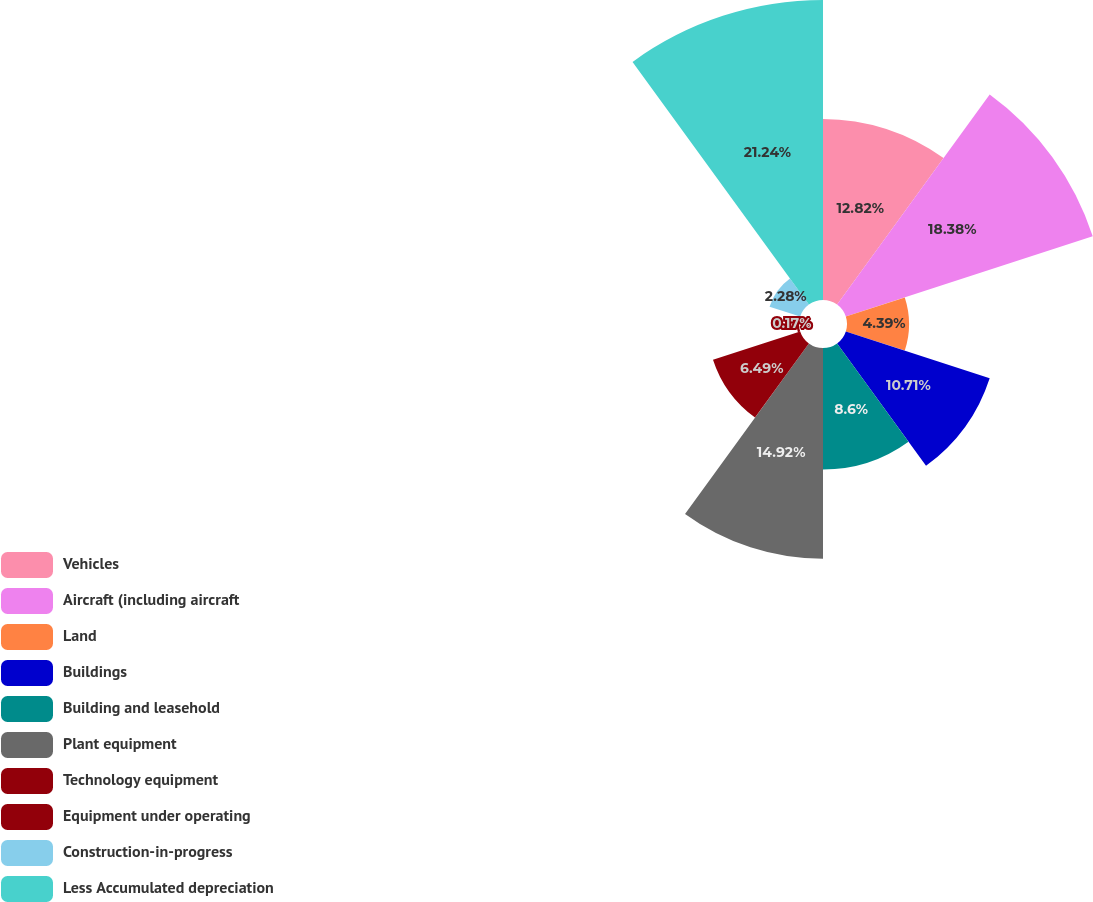Convert chart to OTSL. <chart><loc_0><loc_0><loc_500><loc_500><pie_chart><fcel>Vehicles<fcel>Aircraft (including aircraft<fcel>Land<fcel>Buildings<fcel>Building and leasehold<fcel>Plant equipment<fcel>Technology equipment<fcel>Equipment under operating<fcel>Construction-in-progress<fcel>Less Accumulated depreciation<nl><fcel>12.82%<fcel>18.38%<fcel>4.39%<fcel>10.71%<fcel>8.6%<fcel>14.92%<fcel>6.49%<fcel>0.17%<fcel>2.28%<fcel>21.24%<nl></chart> 